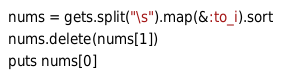Convert code to text. <code><loc_0><loc_0><loc_500><loc_500><_Ruby_>nums = gets.split("\s").map(&:to_i).sort
nums.delete(nums[1])
puts nums[0]
</code> 